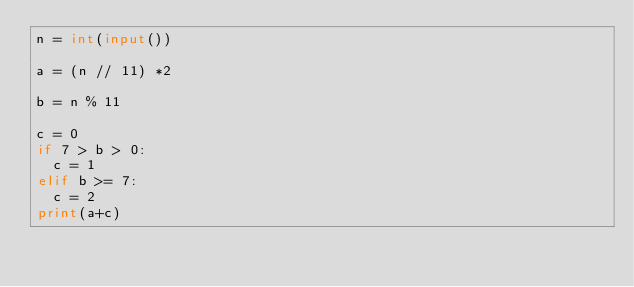<code> <loc_0><loc_0><loc_500><loc_500><_Python_>n = int(input())

a = (n // 11) *2

b = n % 11

c = 0
if 7 > b > 0:
	c = 1
elif b >= 7:
	c = 2
print(a+c)</code> 